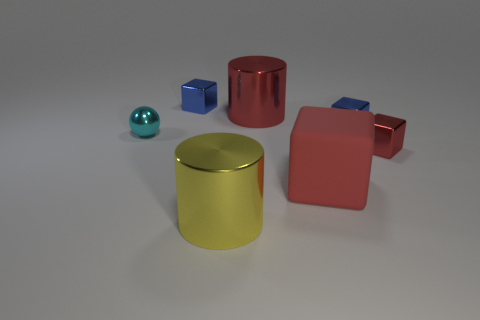What number of objects are small shiny things on the left side of the yellow cylinder or cyan metallic objects?
Provide a succinct answer. 2. Is the tiny cyan thing the same shape as the large red rubber thing?
Ensure brevity in your answer.  No. What number of other things are there of the same size as the cyan metallic thing?
Provide a short and direct response. 3. What color is the sphere?
Provide a short and direct response. Cyan. What number of tiny things are cyan metallic balls or yellow shiny cylinders?
Your answer should be compact. 1. There is a cylinder that is in front of the small cyan metal sphere; is its size the same as the red shiny object in front of the small ball?
Offer a terse response. No. What is the size of the red metal object that is the same shape as the red matte thing?
Offer a very short reply. Small. Are there more large things behind the large red cube than big rubber cubes that are left of the yellow cylinder?
Provide a short and direct response. Yes. There is a large thing that is both right of the large yellow object and in front of the cyan sphere; what is its material?
Give a very brief answer. Rubber. What is the color of the other big object that is the same shape as the big yellow shiny thing?
Ensure brevity in your answer.  Red. 